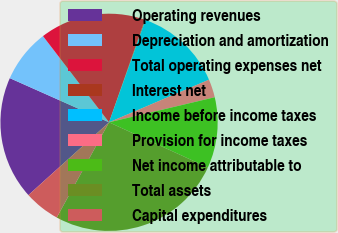Convert chart to OTSL. <chart><loc_0><loc_0><loc_500><loc_500><pie_chart><fcel>Operating revenues<fcel>Depreciation and amortization<fcel>Total operating expenses net<fcel>Interest net<fcel>Income before income taxes<fcel>Provision for income taxes<fcel>Net income attributable to<fcel>Total assets<fcel>Capital expenditures<nl><fcel>18.35%<fcel>7.93%<fcel>15.75%<fcel>0.1%<fcel>13.14%<fcel>2.71%<fcel>10.53%<fcel>26.17%<fcel>5.32%<nl></chart> 